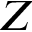Convert formula to latex. <formula><loc_0><loc_0><loc_500><loc_500>Z</formula> 